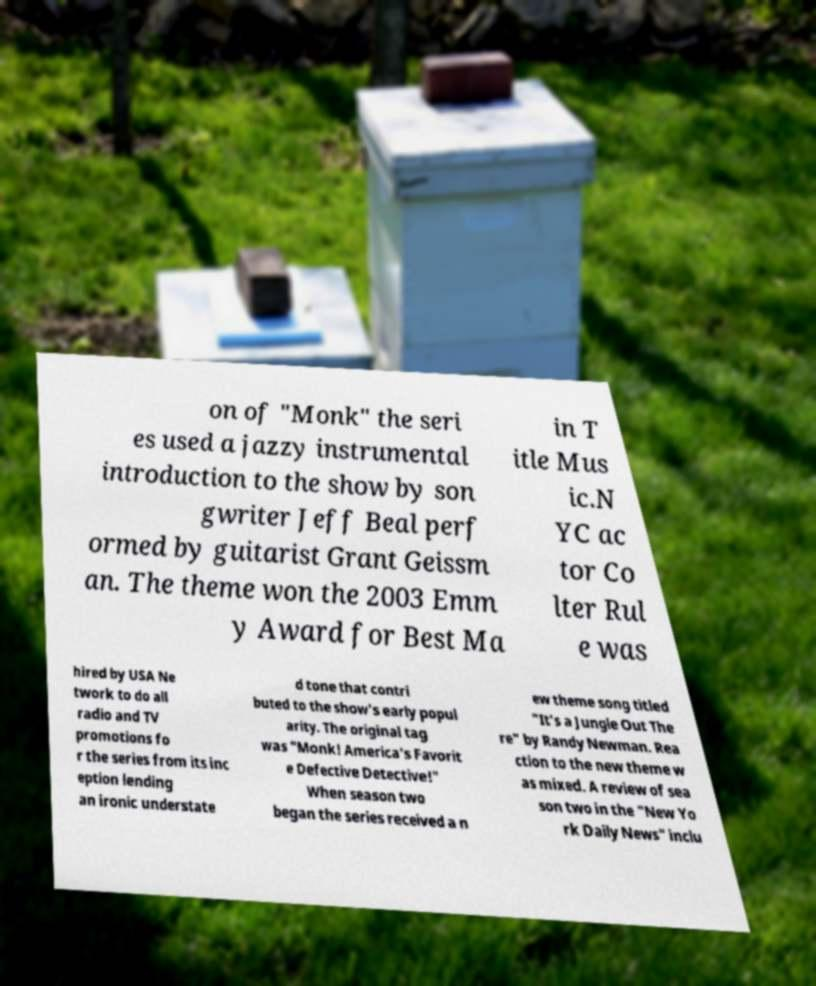Please read and relay the text visible in this image. What does it say? on of "Monk" the seri es used a jazzy instrumental introduction to the show by son gwriter Jeff Beal perf ormed by guitarist Grant Geissm an. The theme won the 2003 Emm y Award for Best Ma in T itle Mus ic.N YC ac tor Co lter Rul e was hired by USA Ne twork to do all radio and TV promotions fo r the series from its inc eption lending an ironic understate d tone that contri buted to the show's early popul arity. The original tag was "Monk! America's Favorit e Defective Detective!" When season two began the series received a n ew theme song titled "It's a Jungle Out The re" by Randy Newman. Rea ction to the new theme w as mixed. A review of sea son two in the "New Yo rk Daily News" inclu 